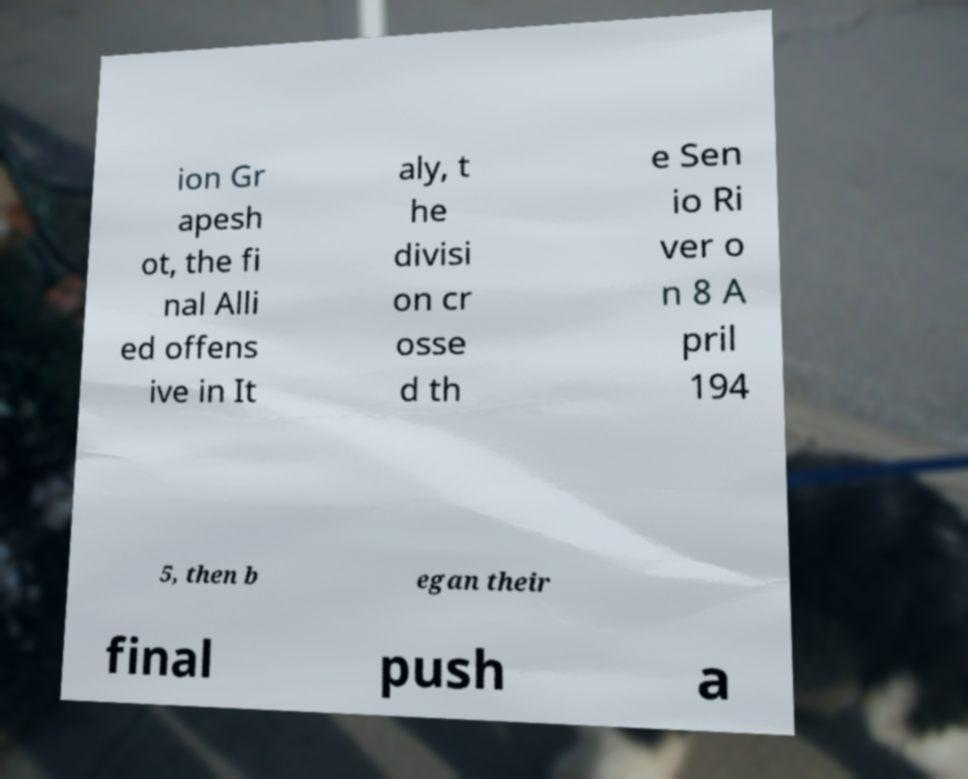Could you assist in decoding the text presented in this image and type it out clearly? ion Gr apesh ot, the fi nal Alli ed offens ive in It aly, t he divisi on cr osse d th e Sen io Ri ver o n 8 A pril 194 5, then b egan their final push a 